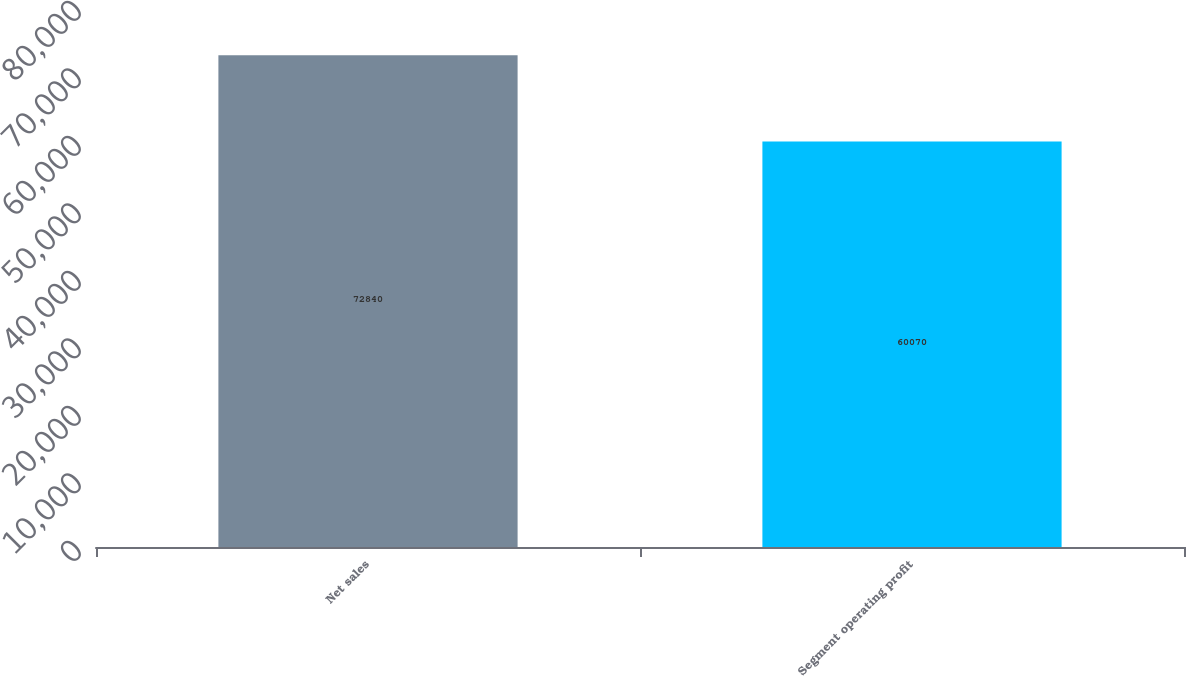Convert chart. <chart><loc_0><loc_0><loc_500><loc_500><bar_chart><fcel>Net sales<fcel>Segment operating profit<nl><fcel>72840<fcel>60070<nl></chart> 